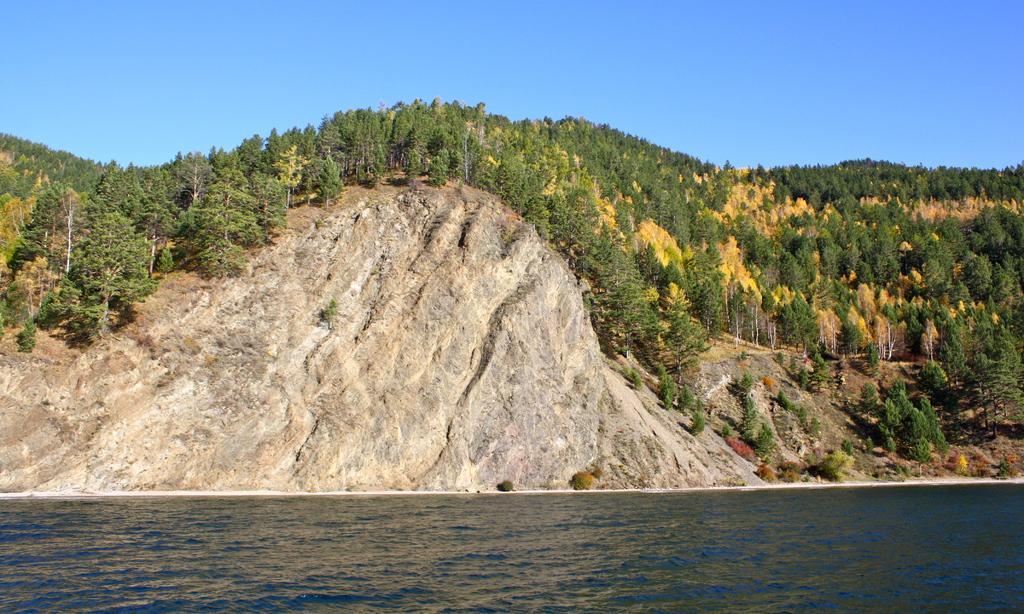Describe this image in one or two sentences. In this image we can see a river flowing, on the other side of the river there are mountains and trees. 